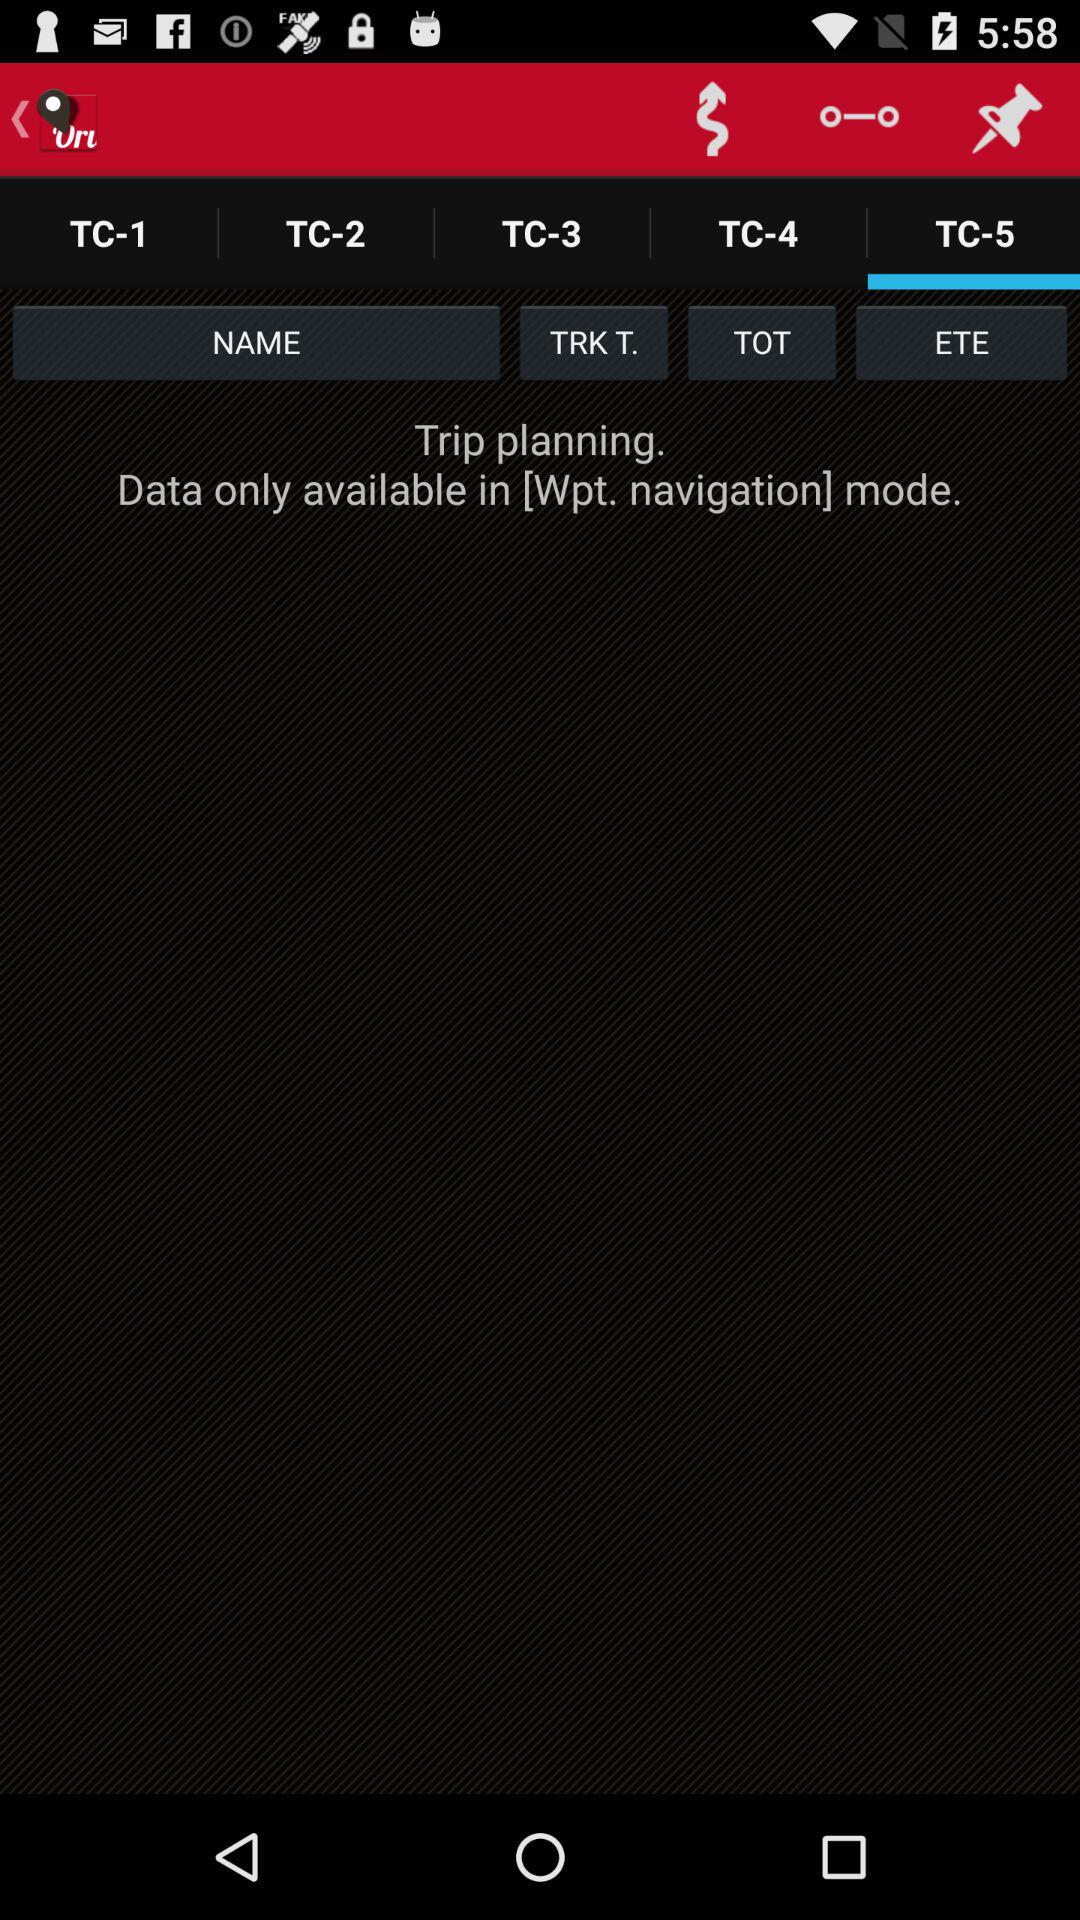Which option is selected? The selected option is "TC-5". 